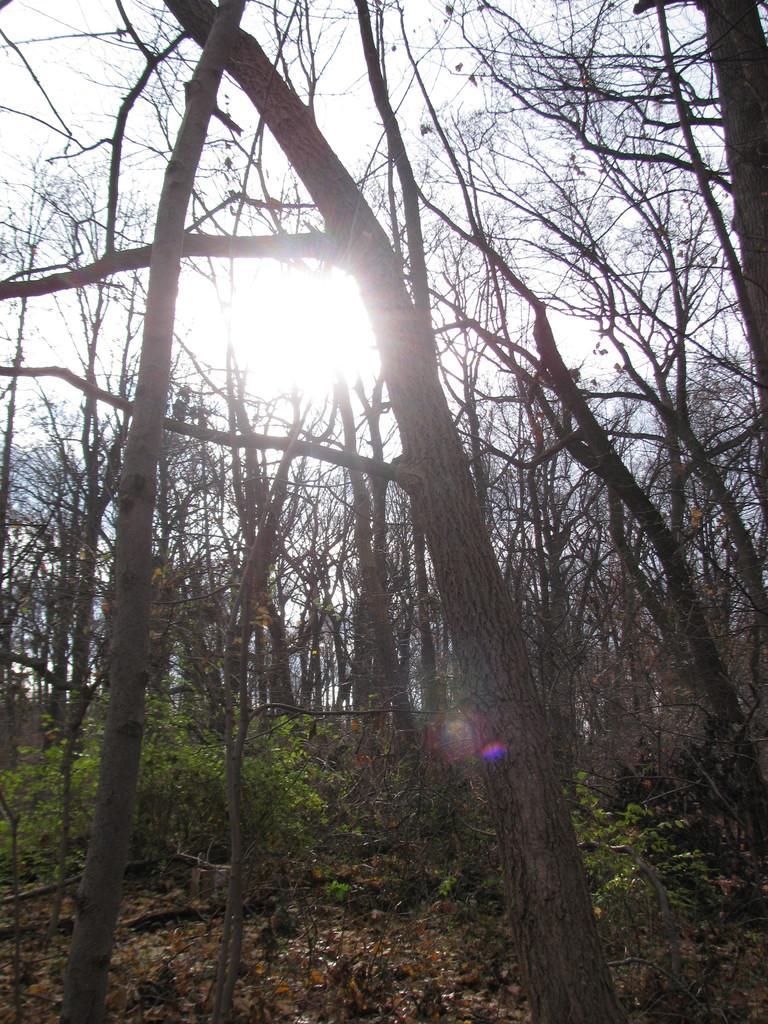In one or two sentences, can you explain what this image depicts? In the picture I can see plants, dry trees, the sun and the sky in the background. 